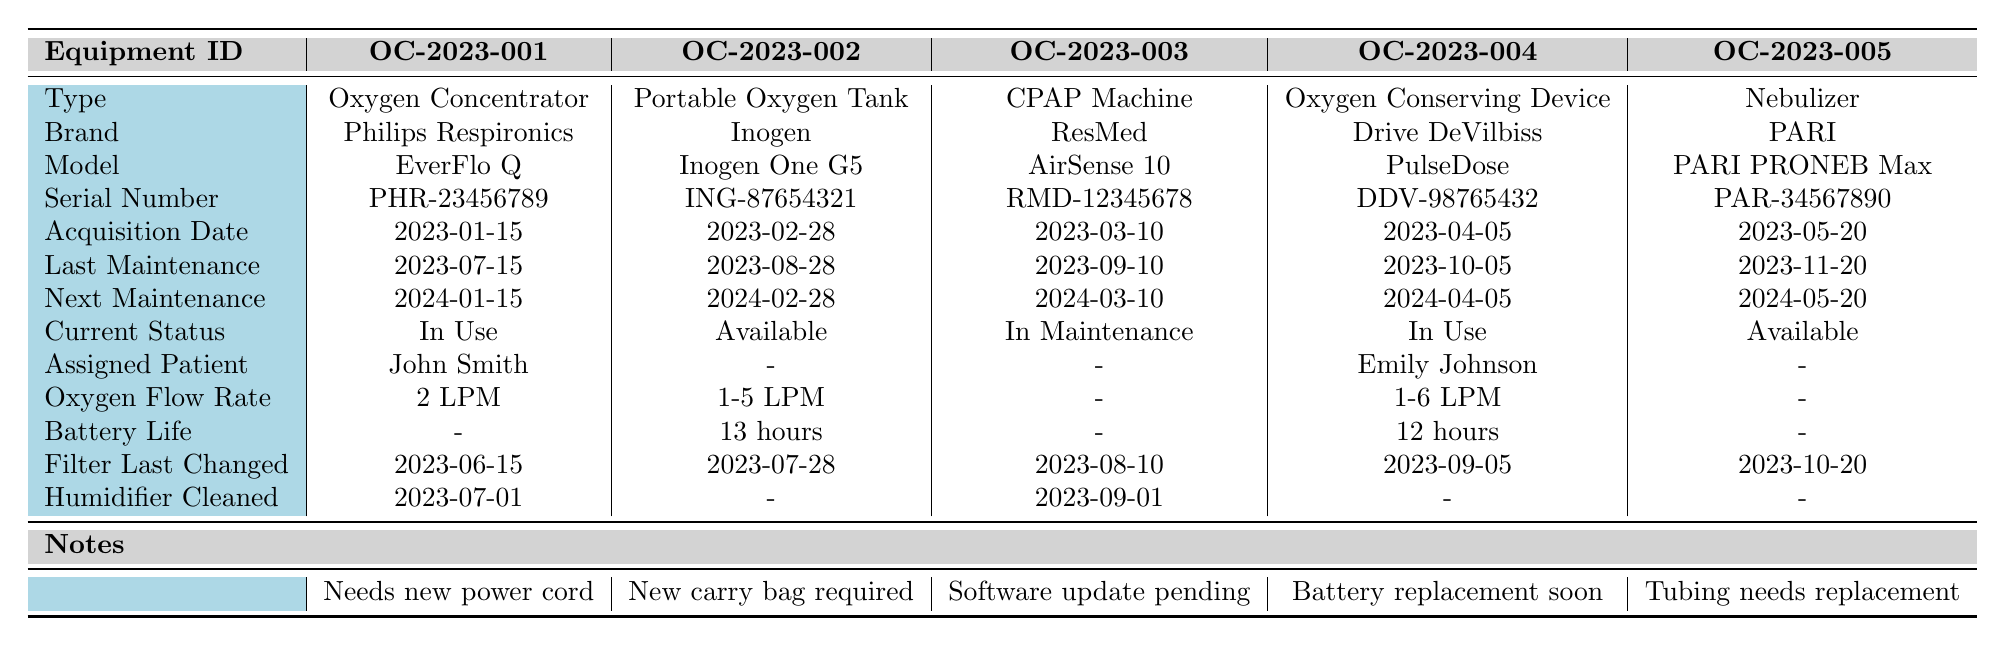What is the current status of the CPAP Machine? The CPAP Machine is listed in the table with its equipment ID as OC-2023-003. According to the "Current Status" row, it is currently "In Maintenance".
Answer: In Maintenance Which equipment has the earliest acquisition date? The equipment with the earliest acquisition date can be found by comparing the "Acquisition Date" values. The dates listed are: 2023-01-15, 2023-02-28, 2023-03-10, 2023-04-05, and 2023-05-20. The earliest is 2023-01-15, corresponding to the Oxygen Concentrator (OC-2023-001).
Answer: Oxygen Concentrator Was there any maintenance conducted on the Portable Oxygen Tank after August 28, 2023? The last maintenance date for the Portable Oxygen Tank (OC-2023-002) is August 28, 2023, and the next maintenance is due on February 28, 2024. Thus, there has been no maintenance since the last recorded date.
Answer: No How many pieces of equipment are currently "In Use"? In the "Current Status" row, there are two pieces of equipment marked as "In Use": the Oxygen Concentrator (OC-2023-001) and the Oxygen Conserving Device (OC-2023-004). Therefore, the count of equipment "In Use" is 2.
Answer: 2 What is the difference in the last maintenance dates between the Oxygen Concentrator and the Nebulizer? The last maintenance date for the Oxygen Concentrator is 2023-07-15, while for the Nebulizer it is 2023-11-20. To find the difference, we calculate: November 20 - July 15 equals 4 months and 5 days.
Answer: 4 months and 5 days For which equipment is a software update pending? The "Notes" row mentions that a software update is pending for the CPAP Machine (OC-2023-003). Therefore, the equipment with a pending software update is identified from the note regarding the CPAP Machine.
Answer: CPAP Machine Which equipment brand has the longest battery life recorded? The only pieces of equipment with recorded battery life are the Portable Oxygen Tank (13 hours) and the Oxygen Conserving Device (12 hours). Since 13 hours is greater than 12 hours, the Portable Oxygen Tank is identified as having the longest battery life.
Answer: Portable Oxygen Tank Which assigned patient has the most recently maintained equipment? The assigned patient to the most recently maintained equipment is determined by comparing the last maintenance dates. The latest date is for the Nebulizer on November 20, 2023, which is unassigned. Meanwhile, equipment assigned to patients is the Oxygen Concentrator with John Smith. Thus, John Smith has the most recently maintained equipment that is assigned.
Answer: John Smith What is the oxygen flow rate of the Oxygen Conserving Device? The oxygen flow rate for the Oxygen Conserving Device (OC-2023-004) is listed in the "Oxygen Flow Rate" row as "1-6 LPM". Thus, this is the answer to the question regarding its flow rate.
Answer: 1-6 LPM Is there any equipment that has not been assigned to a patient? The Portable Oxygen Tank (OC-2023-002) and Nebulizer (OC-2023-005) are both unassigned, as indicated by the dashes in the "Assigned Patient" row. Therefore, the conclusion is yes, there are pieces of equipment that have not been assigned.
Answer: Yes When is the next maintenance due for the equipment assigned to Emily Johnson? The equipment assigned to Emily Johnson is the Oxygen Conserving Device (OC-2023-004), which has the next maintenance due date listed as April 5, 2024. Therefore, the answer can be obtained directly from the table.
Answer: April 5, 2024 